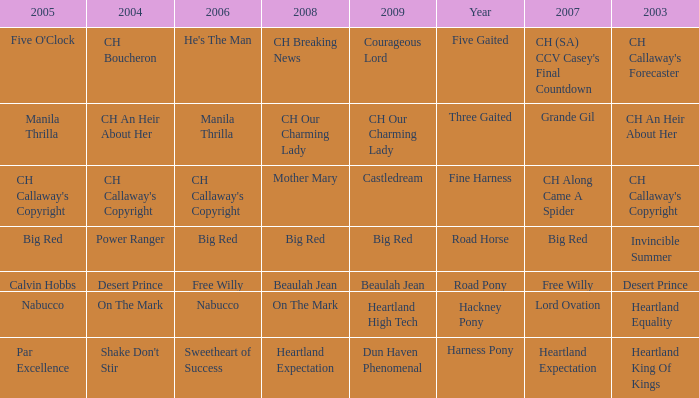What year is the 2004 shake don't stir? Harness Pony. 